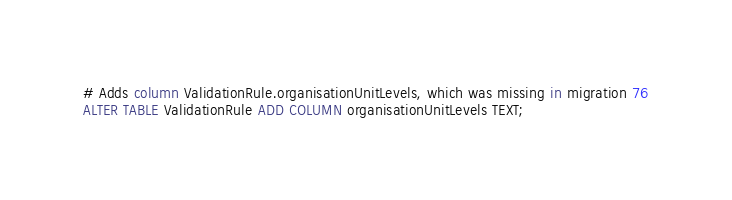<code> <loc_0><loc_0><loc_500><loc_500><_SQL_># Adds column ValidationRule.organisationUnitLevels, which was missing in migration 76
ALTER TABLE ValidationRule ADD COLUMN organisationUnitLevels TEXT;</code> 